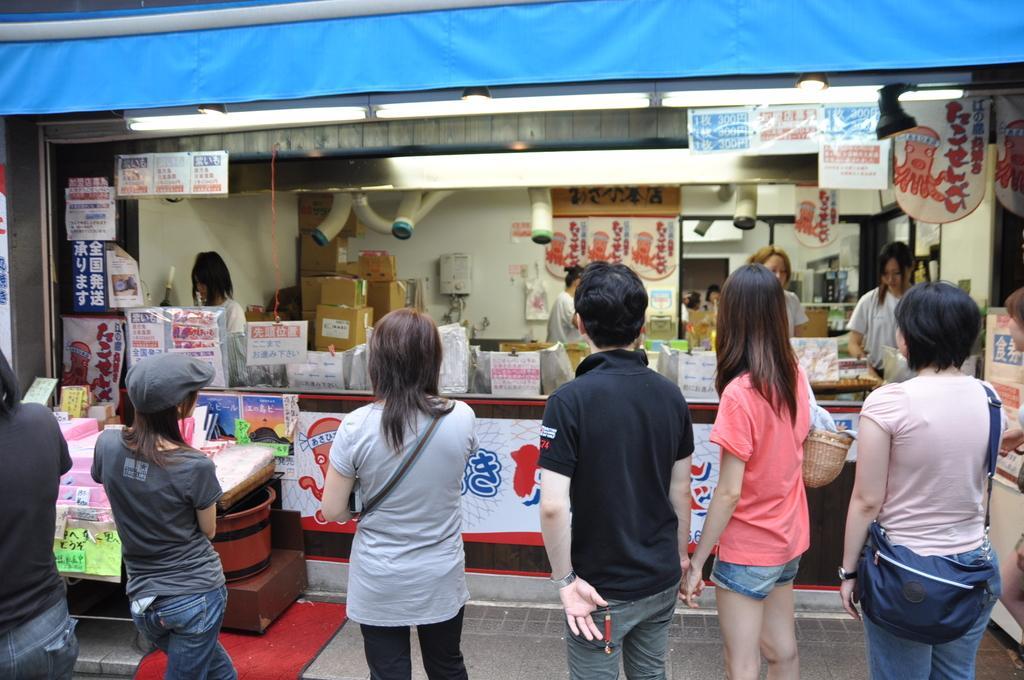Could you give a brief overview of what you see in this image? In this picture we can see people on the ground,here we can see a shop,boxes,posters and some objects. 